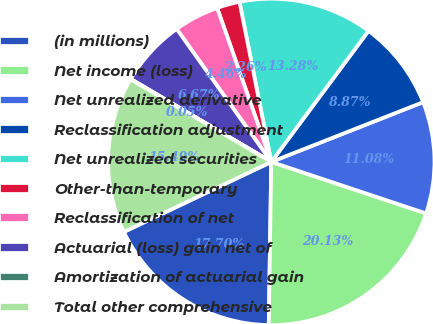Convert chart to OTSL. <chart><loc_0><loc_0><loc_500><loc_500><pie_chart><fcel>(in millions)<fcel>Net income (loss)<fcel>Net unrealized derivative<fcel>Reclassification adjustment<fcel>Net unrealized securities<fcel>Other-than-temporary<fcel>Reclassification of net<fcel>Actuarial (loss) gain net of<fcel>Amortization of actuarial gain<fcel>Total other comprehensive<nl><fcel>17.7%<fcel>20.13%<fcel>11.08%<fcel>8.87%<fcel>13.28%<fcel>2.26%<fcel>4.46%<fcel>6.67%<fcel>0.05%<fcel>15.49%<nl></chart> 